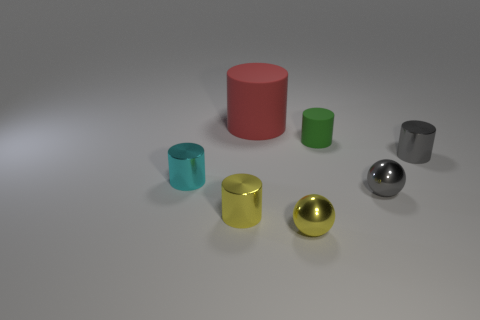Subtract all small green cylinders. How many cylinders are left? 4 Subtract all green cylinders. Subtract all red balls. How many cylinders are left? 4 Add 3 gray cylinders. How many objects exist? 10 Subtract all cylinders. How many objects are left? 2 Subtract 0 yellow cubes. How many objects are left? 7 Subtract all tiny green metal things. Subtract all matte things. How many objects are left? 5 Add 5 big red matte things. How many big red matte things are left? 6 Add 4 tiny metal balls. How many tiny metal balls exist? 6 